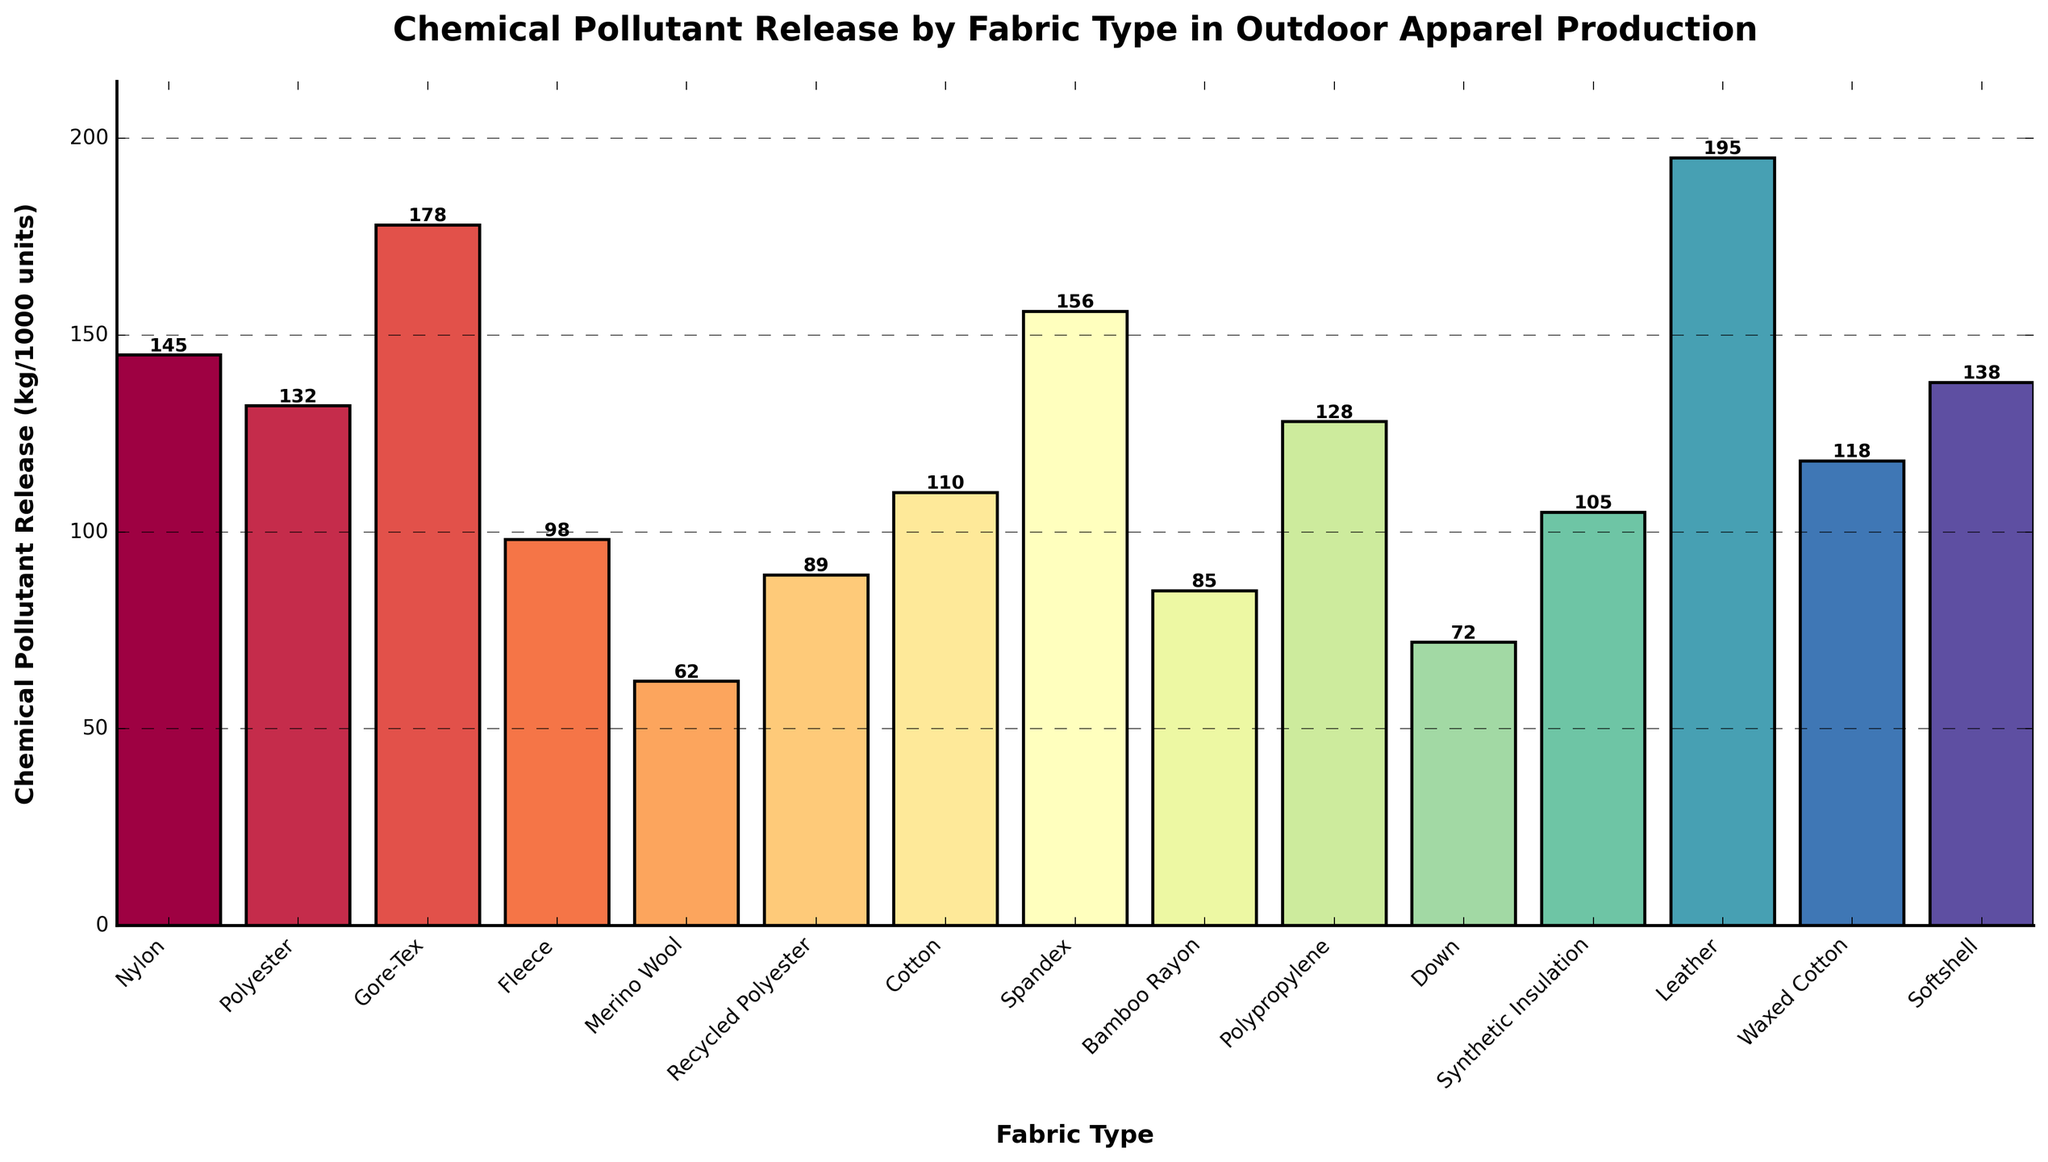Which fabric type has the highest chemical pollutant release? By examining the height of all the bars in the chart, it is evident that the Leather bar is the tallest, indicating the highest chemical pollutant release.
Answer: Leather Which fabric type has the lowest chemical pollutant release? By comparing the heights of the bars, Merino Wool appears to have the shortest bar, indicating the lowest chemical pollutant release.
Answer: Merino Wool What is the difference in chemical pollutant release between Nylon and Spandex? The height of the Nylon bar represents 145 kg, and the height of the Spandex bar represents 156 kg. The difference is calculated by subtracting Nylon's value from Spandex's value: 156 - 145 = 11 kg.
Answer: 11 kg Which fabric types release more than 150 kg of chemical pollutants? Observing the bars, the ones that exceed 150 kg are Gore-Tex (178 kg), Spandex (156 kg), and Leather (195 kg).
Answer: Gore-Tex, Spandex, Leather How much total chemical pollutant is released by Polyester, Recycled Polyester, and Cotton combined? Add the values represented by the heights of these bars: Polyester (132 kg), Recycled Polyester (89 kg), and Cotton (110 kg). The total is 132 + 89 + 110 = 331 kg.
Answer: 331 kg What is the average chemical pollutant release for Nylon, Polyester, and Gore-Tex? Calculate the average by summing the values and dividing by the number of fabric types: (145 + 132 + 178) / 3 = 455 / 3 ≈ 151.67 kg.
Answer: 151.67 kg Which two fabric types have the most similar chemical pollutant release values, and what is the difference between them? By visually comparing the heights, look for bars of similar height. Nylon (145 kg) and Polypropylene (128 kg) are the closest. The difference is 145 - 128 = 17 kg.
Answer: Nylon and Polypropylene, 17 kg What is the combined chemical pollutant release for fabrics that release less than 90 kg? Adding the values for Merino Wool (62 kg), Down (72 kg), and Bamboo Rayon (85 kg): 62 + 72 + 85 = 219 kg.
Answer: 219 kg Which fabric type releases nearly the same amount of pollutants as Waxed Cotton? Comparing the bar heights, Softshell (138 kg) is very close to Waxed Cotton (118 kg). The difference is 20 kg, which is relatively small given the range.
Answer: Softshell 